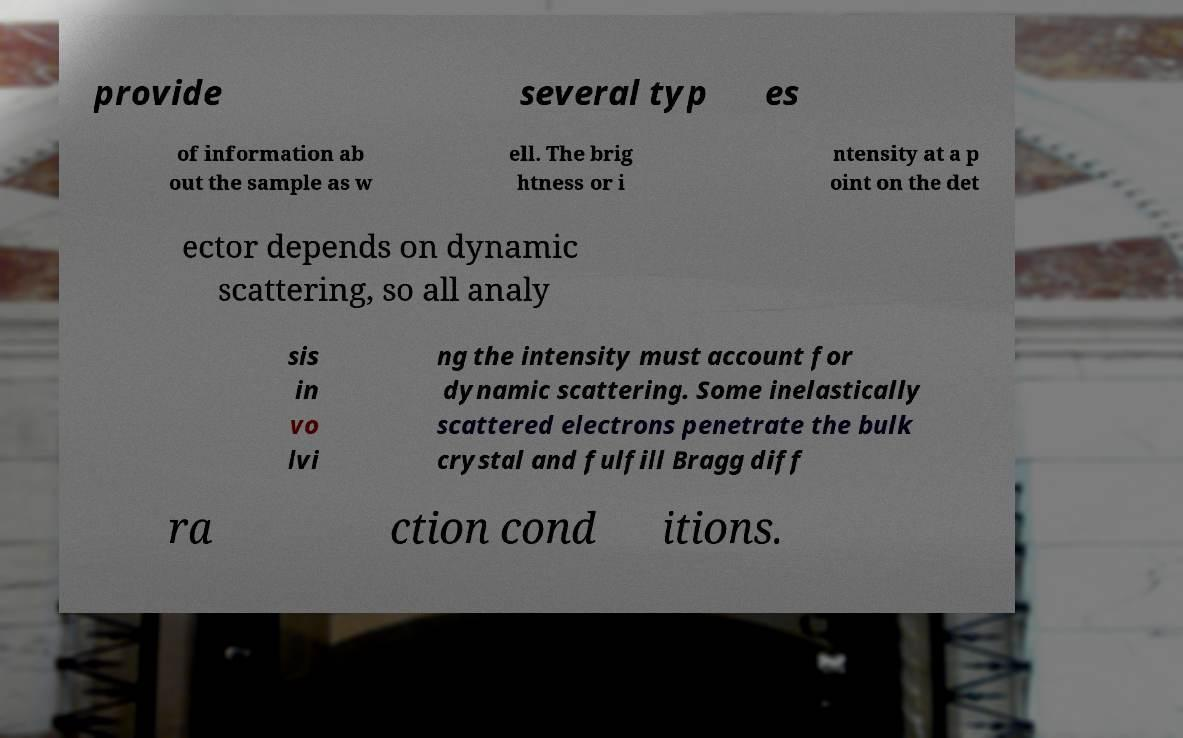For documentation purposes, I need the text within this image transcribed. Could you provide that? provide several typ es of information ab out the sample as w ell. The brig htness or i ntensity at a p oint on the det ector depends on dynamic scattering, so all analy sis in vo lvi ng the intensity must account for dynamic scattering. Some inelastically scattered electrons penetrate the bulk crystal and fulfill Bragg diff ra ction cond itions. 